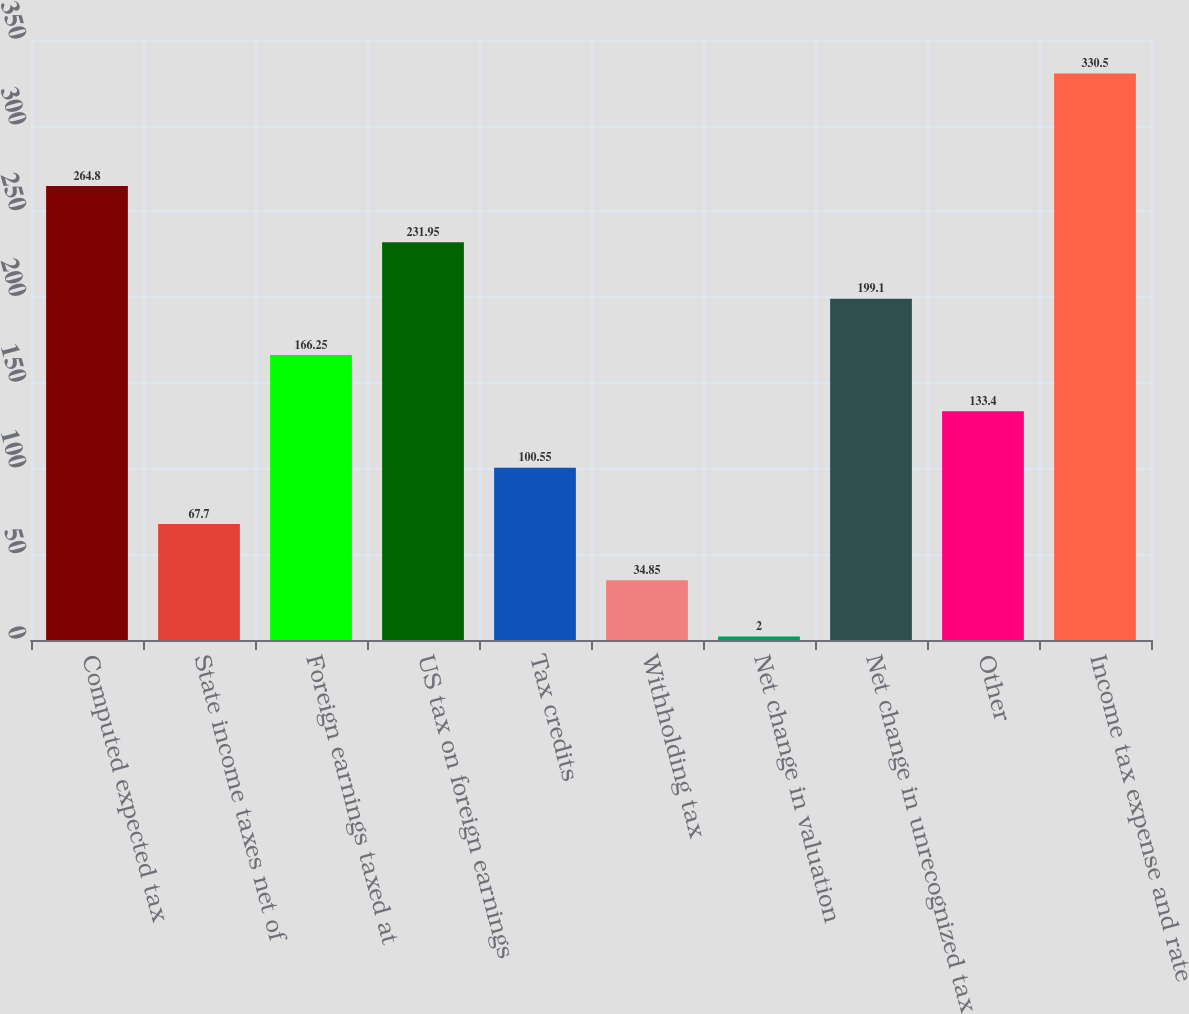Convert chart to OTSL. <chart><loc_0><loc_0><loc_500><loc_500><bar_chart><fcel>Computed expected tax<fcel>State income taxes net of<fcel>Foreign earnings taxed at<fcel>US tax on foreign earnings<fcel>Tax credits<fcel>Withholding tax<fcel>Net change in valuation<fcel>Net change in unrecognized tax<fcel>Other<fcel>Income tax expense and rate<nl><fcel>264.8<fcel>67.7<fcel>166.25<fcel>231.95<fcel>100.55<fcel>34.85<fcel>2<fcel>199.1<fcel>133.4<fcel>330.5<nl></chart> 